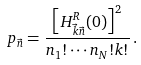Convert formula to latex. <formula><loc_0><loc_0><loc_500><loc_500>p _ { \vec { n } } = \frac { \left [ H ^ { R } _ { \vec { k } \vec { n } } ( 0 ) \right ] ^ { 2 } } { n _ { 1 } ! \cdots n _ { N } ! k ! } \, .</formula> 